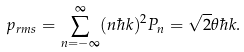Convert formula to latex. <formula><loc_0><loc_0><loc_500><loc_500>p _ { r m s } = \sum _ { n = - \infty } ^ { \infty } ( n \hbar { k } ) ^ { 2 } P _ { n } = { \sqrt { 2 } } \theta \hbar { k } .</formula> 